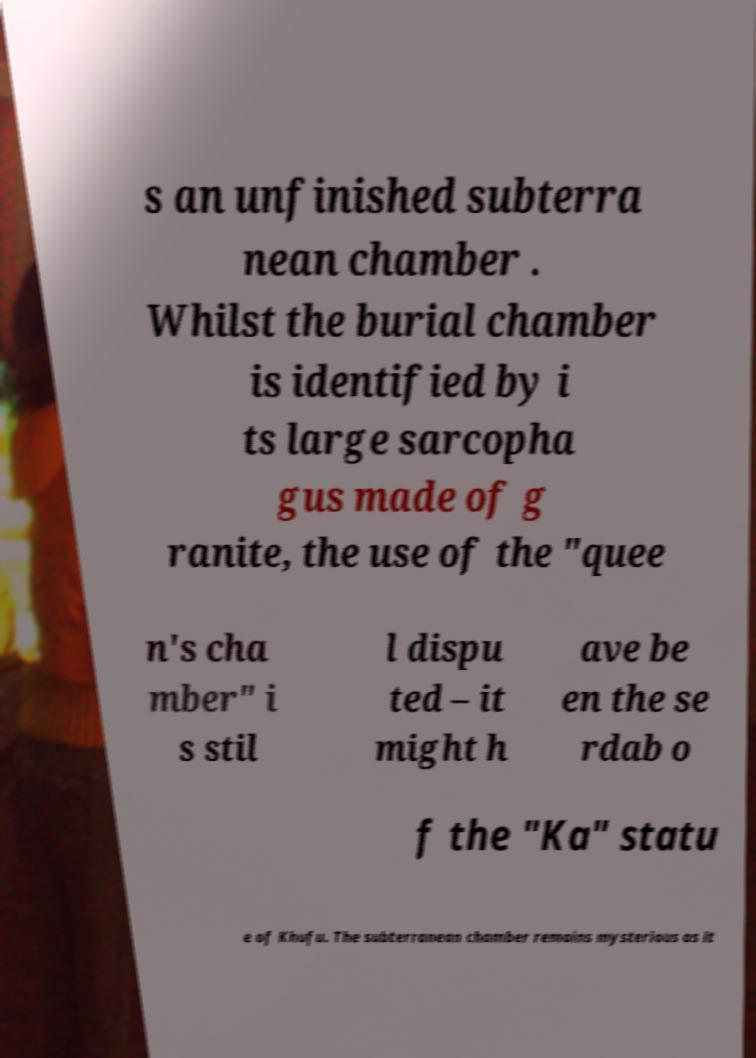Can you read and provide the text displayed in the image?This photo seems to have some interesting text. Can you extract and type it out for me? s an unfinished subterra nean chamber . Whilst the burial chamber is identified by i ts large sarcopha gus made of g ranite, the use of the "quee n's cha mber" i s stil l dispu ted – it might h ave be en the se rdab o f the "Ka" statu e of Khufu. The subterranean chamber remains mysterious as it 